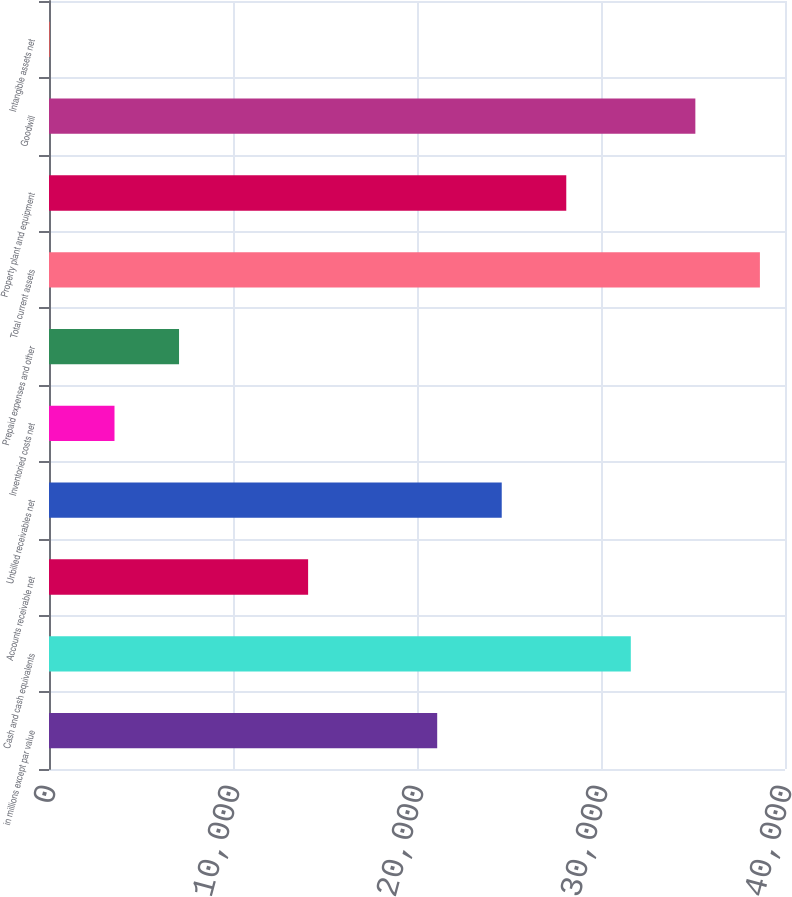<chart> <loc_0><loc_0><loc_500><loc_500><bar_chart><fcel>in millions except par value<fcel>Cash and cash equivalents<fcel>Accounts receivable net<fcel>Unbilled receivables net<fcel>Inventoried costs net<fcel>Prepaid expenses and other<fcel>Total current assets<fcel>Property plant and equipment<fcel>Goodwill<fcel>Intangible assets net<nl><fcel>21097.6<fcel>31620.4<fcel>14082.4<fcel>24605.2<fcel>3559.6<fcel>7067.2<fcel>38635.6<fcel>28112.8<fcel>35128<fcel>52<nl></chart> 